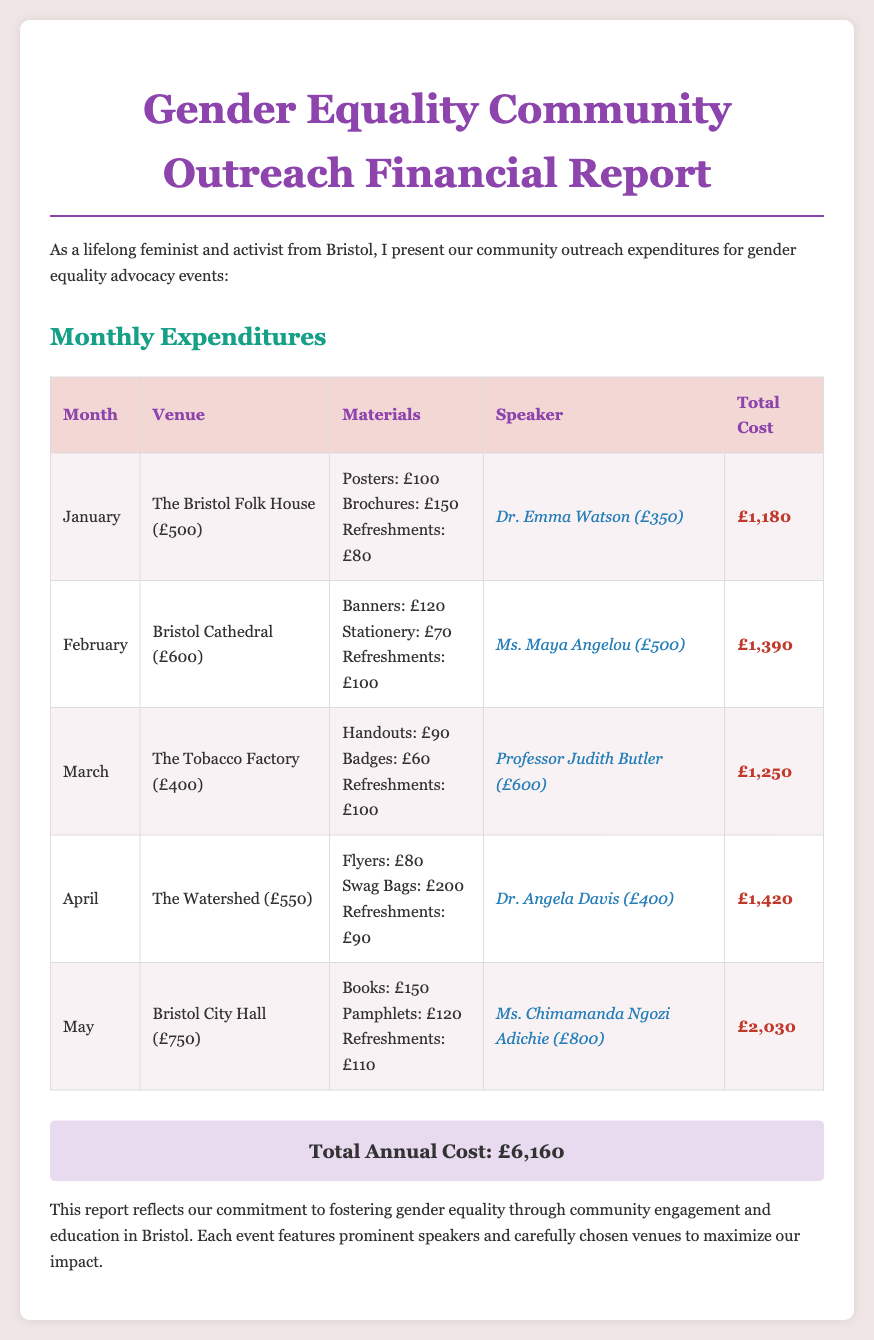What was the total expenditure for May? The total expenditure for May is found in the table under the total cost for that month.
Answer: £2,030 Who was the speaker in January? The speaker in January is listed in the table under the speaker column for that month.
Answer: Dr. Emma Watson Which venue had the highest cost? The venue with the highest cost is determined by comparing the venue costs listed for each month in the table.
Answer: Bristol City Hall (£750) What is the total annual cost of all events? The total annual cost is provided as a summary at the end of the report.
Answer: £6,160 What month incurred the lowest total expenditure? The month with the lowest total expenditure can be determined by evaluating the costs for each month displayed in the document.
Answer: January (£1,180) 